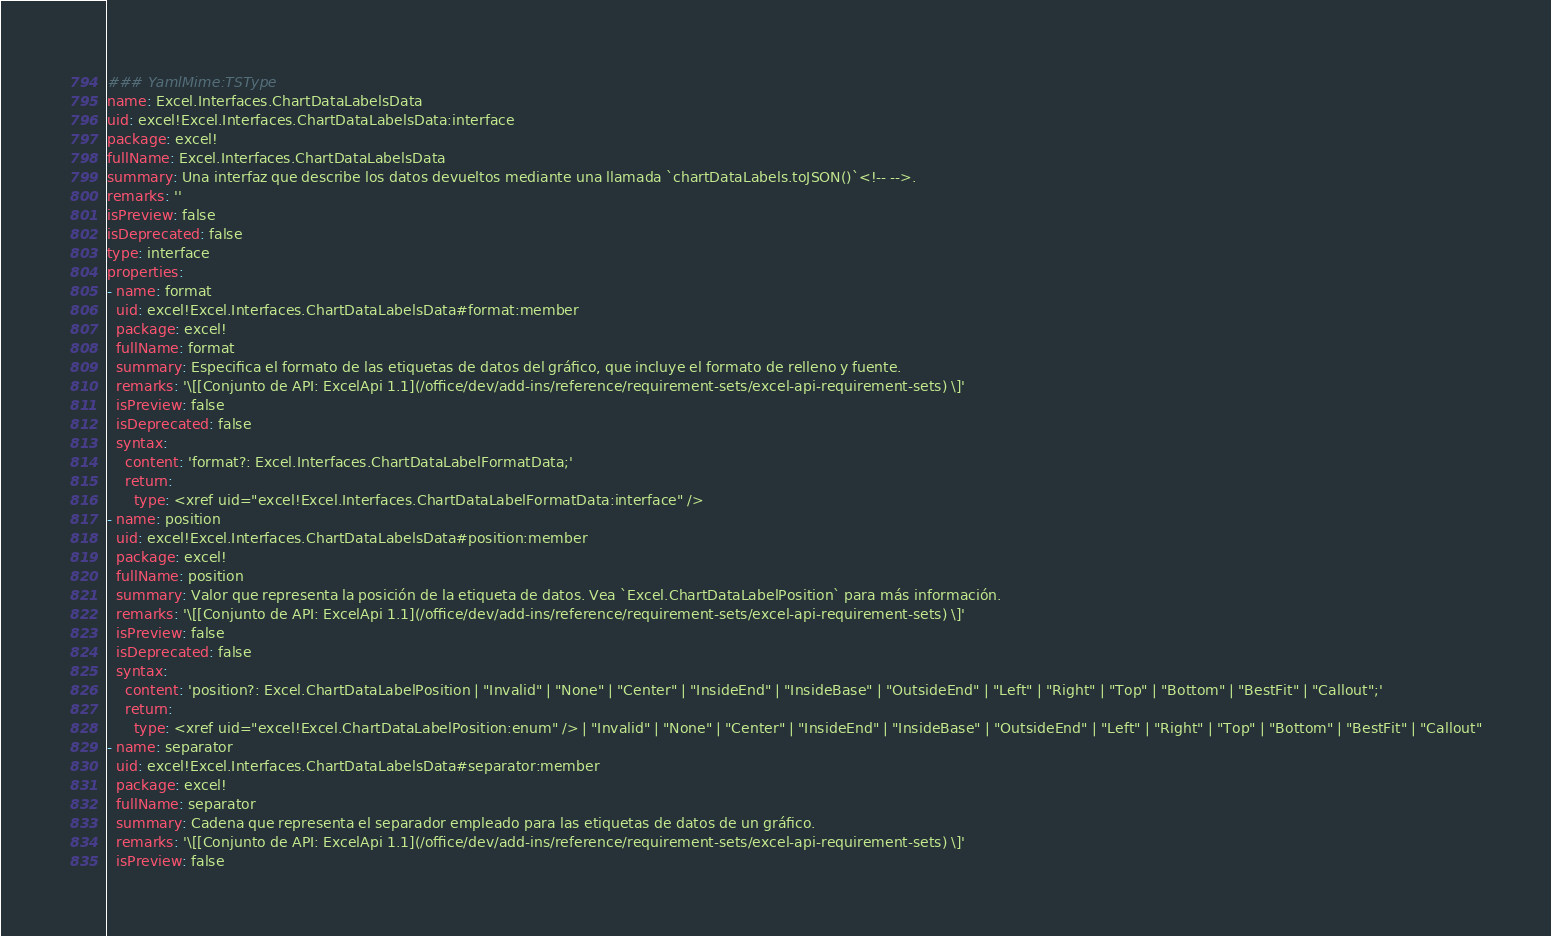<code> <loc_0><loc_0><loc_500><loc_500><_YAML_>### YamlMime:TSType
name: Excel.Interfaces.ChartDataLabelsData
uid: excel!Excel.Interfaces.ChartDataLabelsData:interface
package: excel!
fullName: Excel.Interfaces.ChartDataLabelsData
summary: Una interfaz que describe los datos devueltos mediante una llamada `chartDataLabels.toJSON()`<!-- -->.
remarks: ''
isPreview: false
isDeprecated: false
type: interface
properties:
- name: format
  uid: excel!Excel.Interfaces.ChartDataLabelsData#format:member
  package: excel!
  fullName: format
  summary: Especifica el formato de las etiquetas de datos del gráfico, que incluye el formato de relleno y fuente.
  remarks: '\[[Conjunto de API: ExcelApi 1.1](/office/dev/add-ins/reference/requirement-sets/excel-api-requirement-sets) \]'
  isPreview: false
  isDeprecated: false
  syntax:
    content: 'format?: Excel.Interfaces.ChartDataLabelFormatData;'
    return:
      type: <xref uid="excel!Excel.Interfaces.ChartDataLabelFormatData:interface" />
- name: position
  uid: excel!Excel.Interfaces.ChartDataLabelsData#position:member
  package: excel!
  fullName: position
  summary: Valor que representa la posición de la etiqueta de datos. Vea `Excel.ChartDataLabelPosition` para más información.
  remarks: '\[[Conjunto de API: ExcelApi 1.1](/office/dev/add-ins/reference/requirement-sets/excel-api-requirement-sets) \]'
  isPreview: false
  isDeprecated: false
  syntax:
    content: 'position?: Excel.ChartDataLabelPosition | "Invalid" | "None" | "Center" | "InsideEnd" | "InsideBase" | "OutsideEnd" | "Left" | "Right" | "Top" | "Bottom" | "BestFit" | "Callout";'
    return:
      type: <xref uid="excel!Excel.ChartDataLabelPosition:enum" /> | "Invalid" | "None" | "Center" | "InsideEnd" | "InsideBase" | "OutsideEnd" | "Left" | "Right" | "Top" | "Bottom" | "BestFit" | "Callout"
- name: separator
  uid: excel!Excel.Interfaces.ChartDataLabelsData#separator:member
  package: excel!
  fullName: separator
  summary: Cadena que representa el separador empleado para las etiquetas de datos de un gráfico.
  remarks: '\[[Conjunto de API: ExcelApi 1.1](/office/dev/add-ins/reference/requirement-sets/excel-api-requirement-sets) \]'
  isPreview: false</code> 